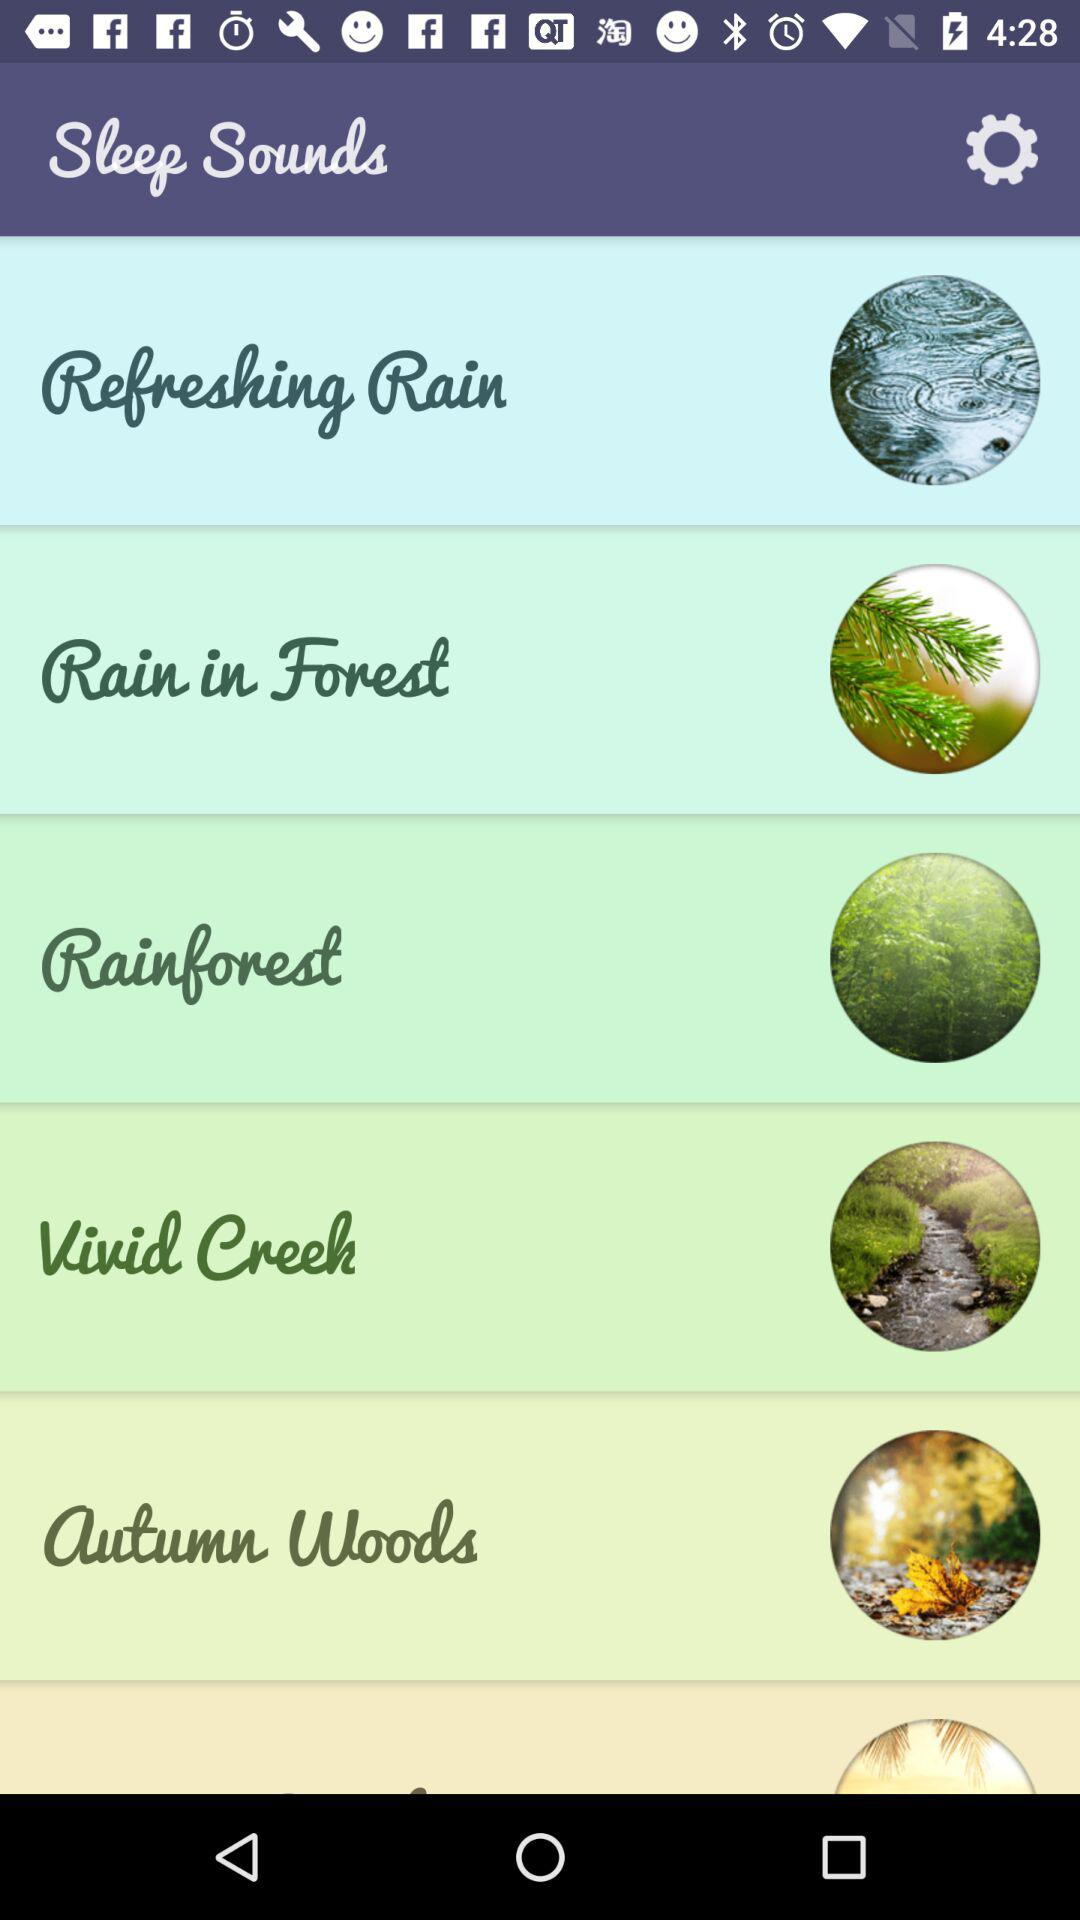What is the application name? The application name is "Sleep Sounds". 